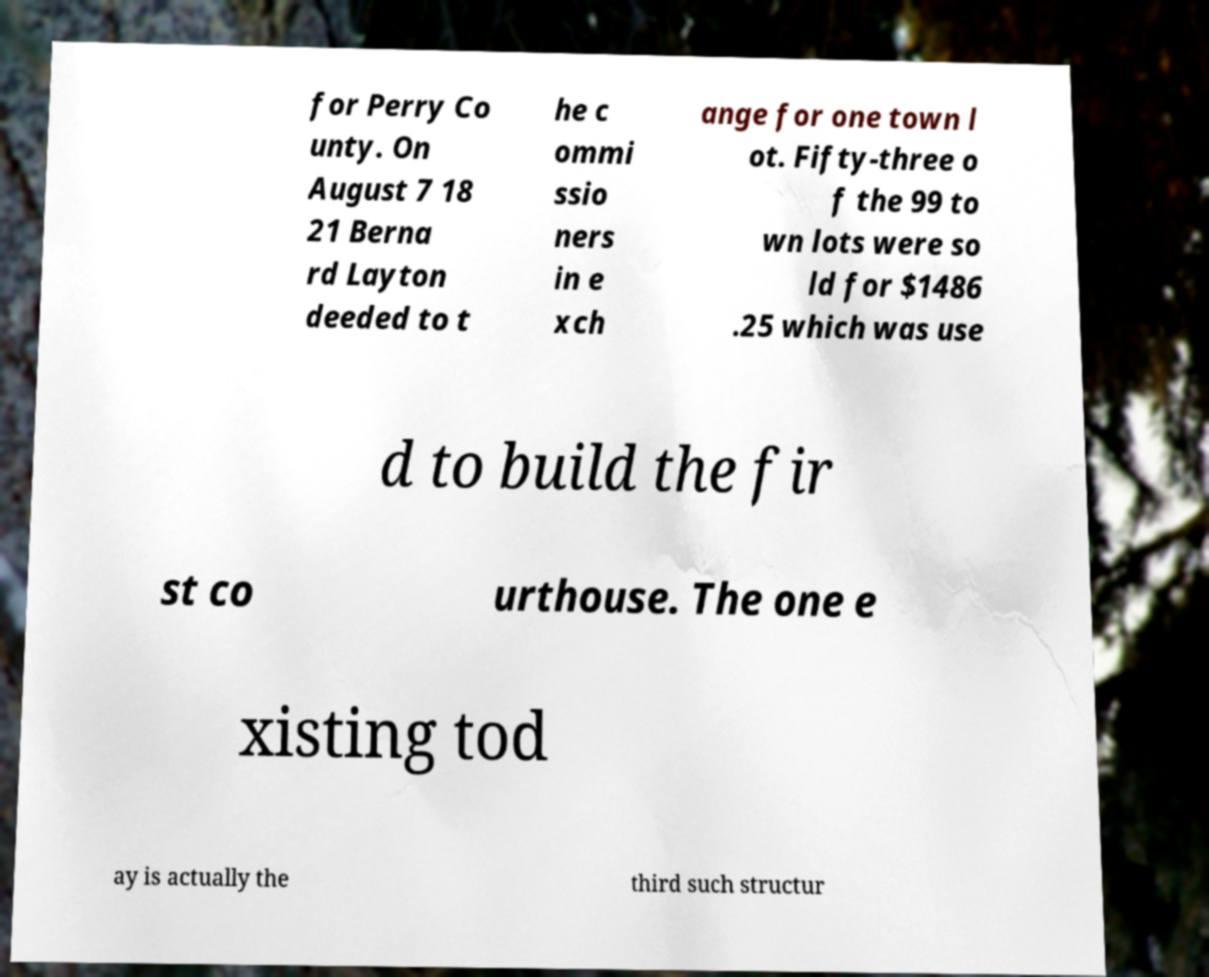Can you accurately transcribe the text from the provided image for me? for Perry Co unty. On August 7 18 21 Berna rd Layton deeded to t he c ommi ssio ners in e xch ange for one town l ot. Fifty-three o f the 99 to wn lots were so ld for $1486 .25 which was use d to build the fir st co urthouse. The one e xisting tod ay is actually the third such structur 